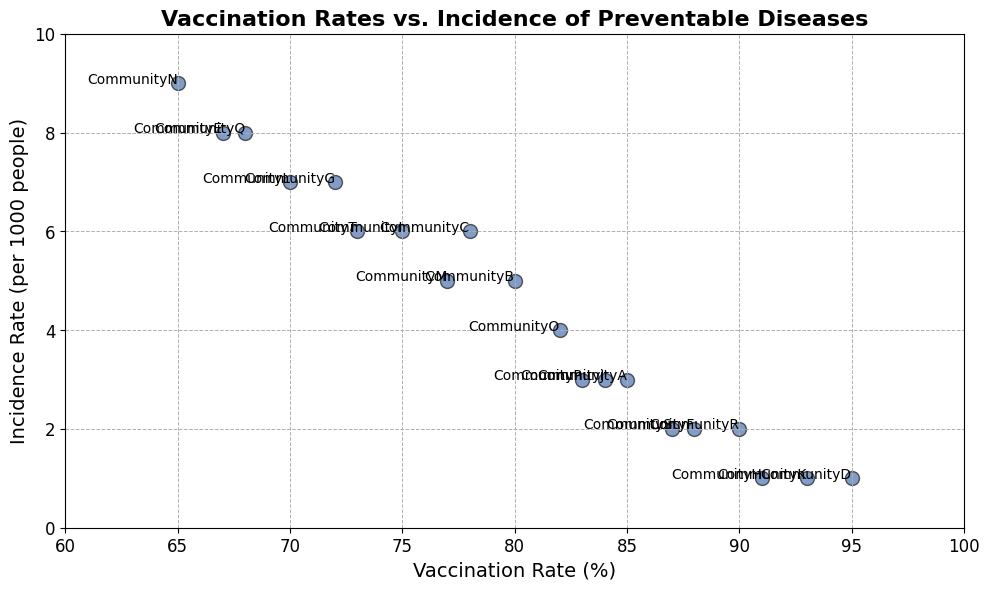What's the community with the highest vaccination rate? Look for the data point on the x-axis (Vaccination Rate) that is furthest to the right. Annotating this point will reveal the community name.
Answer: CommunityD Which communities have an incidence rate of 1? Find the data points on the y-axis (Incidence Rate) at the value of 1 and check the community names associated with those points.
Answer: CommunityD, CommunityH, CommunityK What is the average incidence rate for communities with a vaccination rate above 80%? Identify communities with vaccination rates greater than 80%. These communities are CommunityA, CommunityB, CommunityD, CommunityF, CommunityH, CommunityK, CommunityO, CommunityP, CommunityR, and CommunityS. Next, average their incidence rates: (3 + 5 + 1 + 2 + 1 + 1 + 4 + 3 + 2 + 2)/10 = 2.4.
Answer: 2.4 Which community has the greatest difference between vaccination rate and incidence rate? Calculate the difference between vaccination rate and incidence rate for each community. Identify the community with the largest difference: CommunityD (95 - 1 = 94), which is the maximum value.
Answer: CommunityD List the communities with a vaccination rate below 70%. Look at the communities with data points positioned to the left of the 70% mark on the x-axis.
Answer: CommunityE, CommunityN, CommunityQ How many communities have a vaccination rate lower than 75% and an incidence rate higher than 6? Identify data points where the vaccination rate is less than 75% and the incidence rate is more than 6. These communities are CommunityL and CommunityN.
Answer: 2 What vaccination rate corresponds to the median incidence rate? First, list the incidence rates in ascending order: 1, 1, 1, 2, 2, 2, 3, 3, 3, 4, 5, 5, 6, 6, 6, 6, 7, 7, 8, 8, 9. The median incidence rate is the 11th value, which is 5. The communities with this incidence rate are CommunityB and CommunityM with corresponding vaccination rates of 80 and 77. Thus, the median vaccination rate is 77.
Answer: 77 Which communities fall within the vaccination rate range of 80-85% and what are their incidence rates? Identify communities with vaccination rates between 80 and 85%. These communities are CommunityA (85, 3), CommunityB (80, 5), and CommunityJ (84, 3), and CommunityP (83, 3). Their incidence rates are 3, 5, 3, and 3 respectively.
Answer: CommunityA: 3, CommunityB: 5, CommunityJ: 3, CommunityP: 3 Is there any community with both below 70% vaccination rate and below 5 incidence rate? Check for communities where both the vaccination rate is less than 70% and the incidence rate is below 5. No such data point meets both conditions simultaneously.
Answer: No 